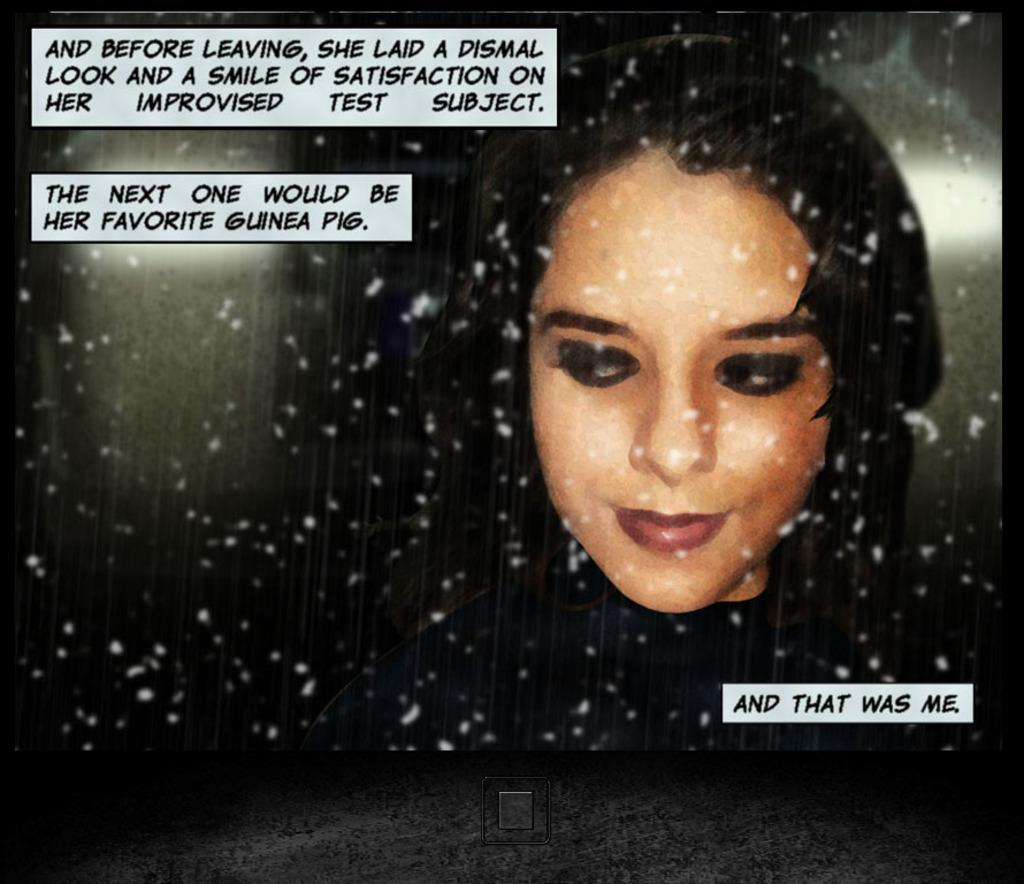Who is present in the image? There is a lady in the image. What else can be seen in the image besides the lady? There is text on the image. Where is the button located in the image? The button is at the bottom of the image. What type of pollution is visible in the image? There is no pollution visible in the image; it only contains a lady, text, and a button. Where is the toothpaste located in the image? There is no toothpaste present in the image. 